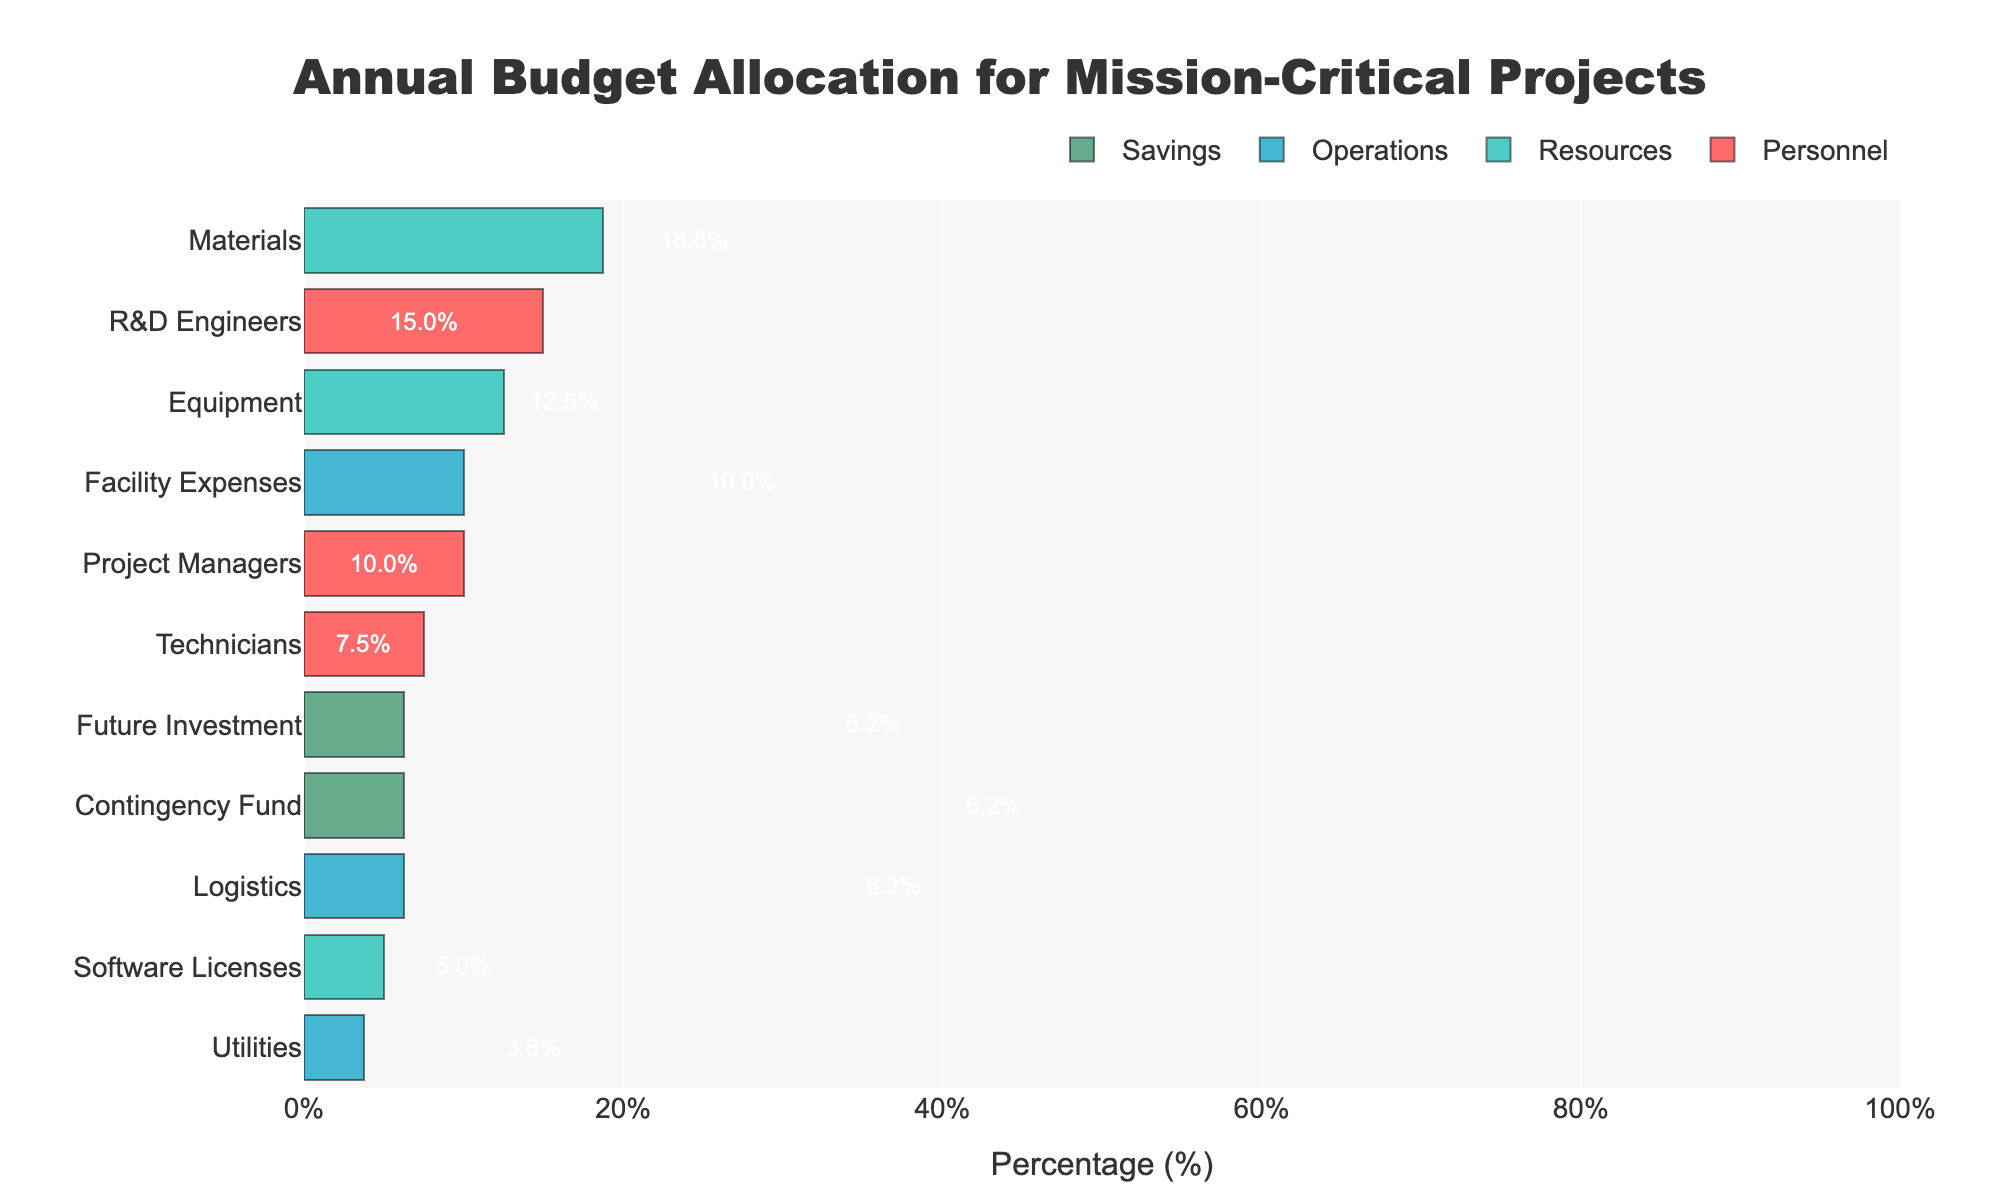What is the combined budget percentage allocated to "Personnel" costs? To find the combined budget percentage for "Personnel" costs, sum the percentages allocated to "R&D Engineers", "Project Managers", and "Technicians". This gives 15% + 10% + 7.5% = 32.5%.
Answer: 32.5% Which category has the highest individual budget allocation among "Resources"? Among the "Resources" category, the highest individual budget allocation goes to "Materials" with 18.75%.
Answer: Materials What's the difference in budget percentage between "Materials" and "Equipment"? In the "Resources" category, the budget for "Materials" is 18.75% and for "Equipment" is 12.5%. The difference is 18.75% - 12.5% = 6.25%.
Answer: 6.25% Which "Operations" entity receives the least budget allocation? By looking at the "Operations" category, "Utilities" receives the least budget allocation with 3.75%.
Answer: Utilities Compare the total budget percentages allocated to "Resources" and "Operations". Which one is higher, and by how much? Sum up the percentages for "Resources" (18.75% + 12.5% + 5% = 36.25%) and for "Operations" (6.25% + 10% + 3.75% = 20%). "Resources" is higher by 36.25% - 20% = 16.25%.
Answer: Resources by 16.25% How much higher is the budget percentage allocation for "Contingency Fund" than for "Utilities"? "Contingency Fund" is allocated 6.25% of the budget, while "Utilities" has 3.75%. The difference is 6.25% - 3.75% = 2.5%.
Answer: 2.5% What is the total budget percentage for "Savings"? Combine the percentages for "Contingency Fund" (6.25%) and "Future Investment" (6.25%). This totals 6.25% + 6.25% = 12.5%.
Answer: 12.5% Rank the "Personnel" entities by their budget allocation from highest to lowest. Looking at the "Personnel" entities: "R&D Engineers" (15%), "Project Managers" (10%), "Technicians" (7.5%). Therefore, the ranking from highest to lowest is: "R&D Engineers", "Project Managers", "Technicians".
Answer: R&D Engineers, Project Managers, Technicians What is the average budget percentage allocated to each of "R&D Engineers", "Project Managers", and "Technicians"? Sum the budget percentages for "R&D Engineers" (15%), "Project Managers" (10%), and "Technicians" (7.5%), then divide by the number of entities (3). This gives (15% + 10% + 7.5%) / 3 = 10.83%.
Answer: 10.83% Which categories have the same percentage of their budget allocated? Both "Contingency Fund" and "Future Investment" under the "Savings" category have an allocation of 6.25%.
Answer: Contingency Fund and Future Investment 